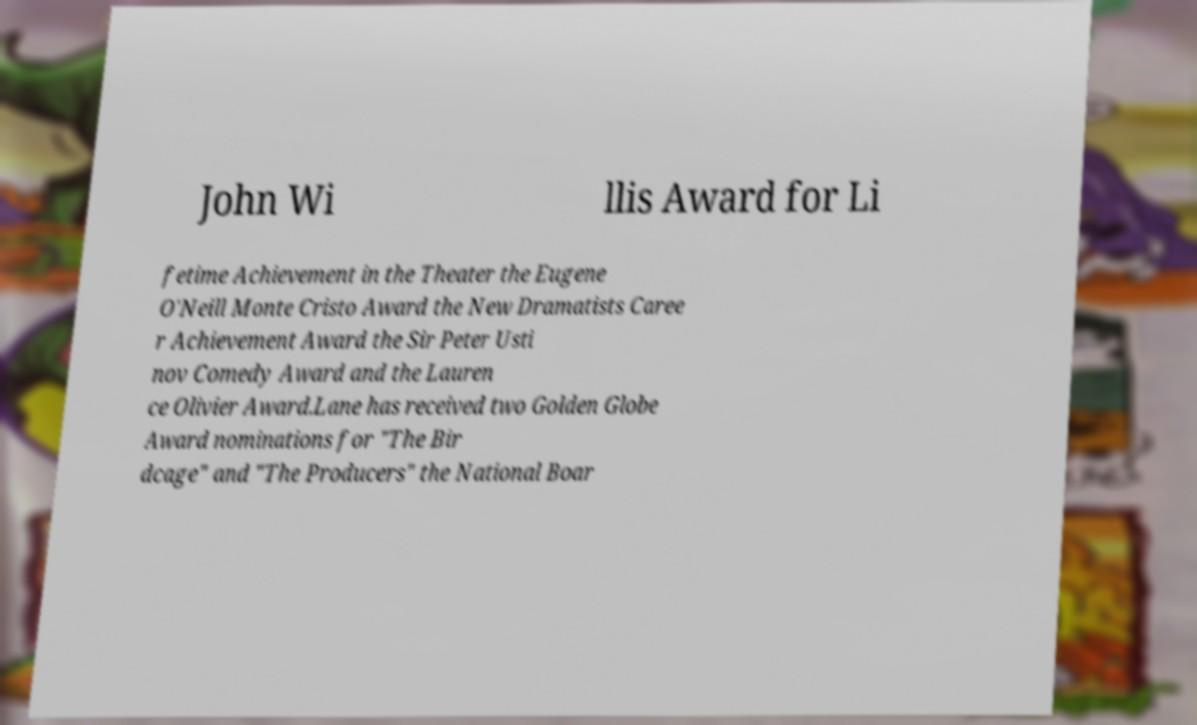There's text embedded in this image that I need extracted. Can you transcribe it verbatim? John Wi llis Award for Li fetime Achievement in the Theater the Eugene O'Neill Monte Cristo Award the New Dramatists Caree r Achievement Award the Sir Peter Usti nov Comedy Award and the Lauren ce Olivier Award.Lane has received two Golden Globe Award nominations for "The Bir dcage" and "The Producers" the National Boar 